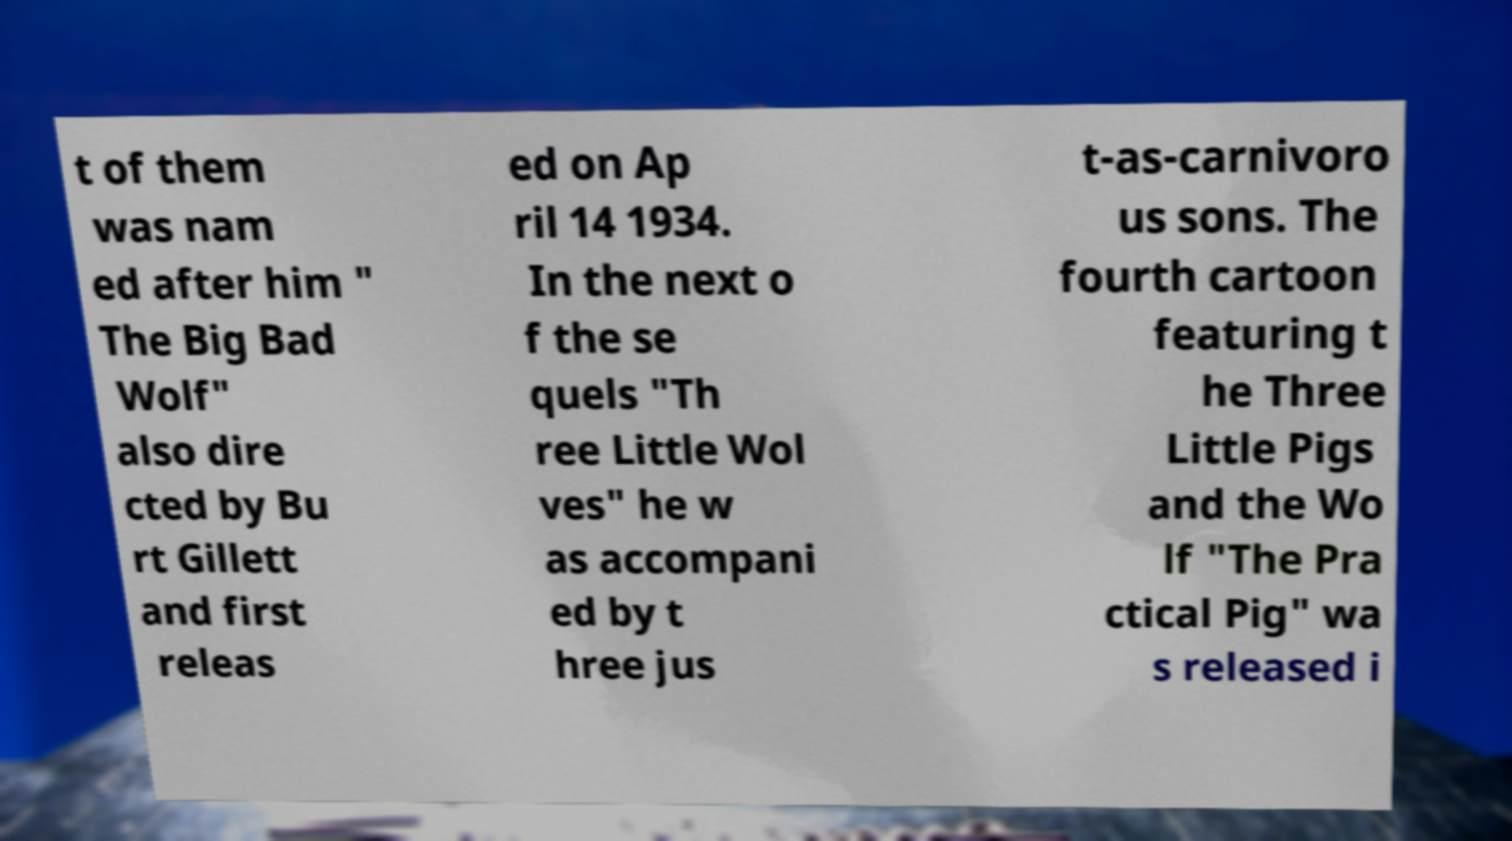There's text embedded in this image that I need extracted. Can you transcribe it verbatim? t of them was nam ed after him " The Big Bad Wolf" also dire cted by Bu rt Gillett and first releas ed on Ap ril 14 1934. In the next o f the se quels "Th ree Little Wol ves" he w as accompani ed by t hree jus t-as-carnivoro us sons. The fourth cartoon featuring t he Three Little Pigs and the Wo lf "The Pra ctical Pig" wa s released i 